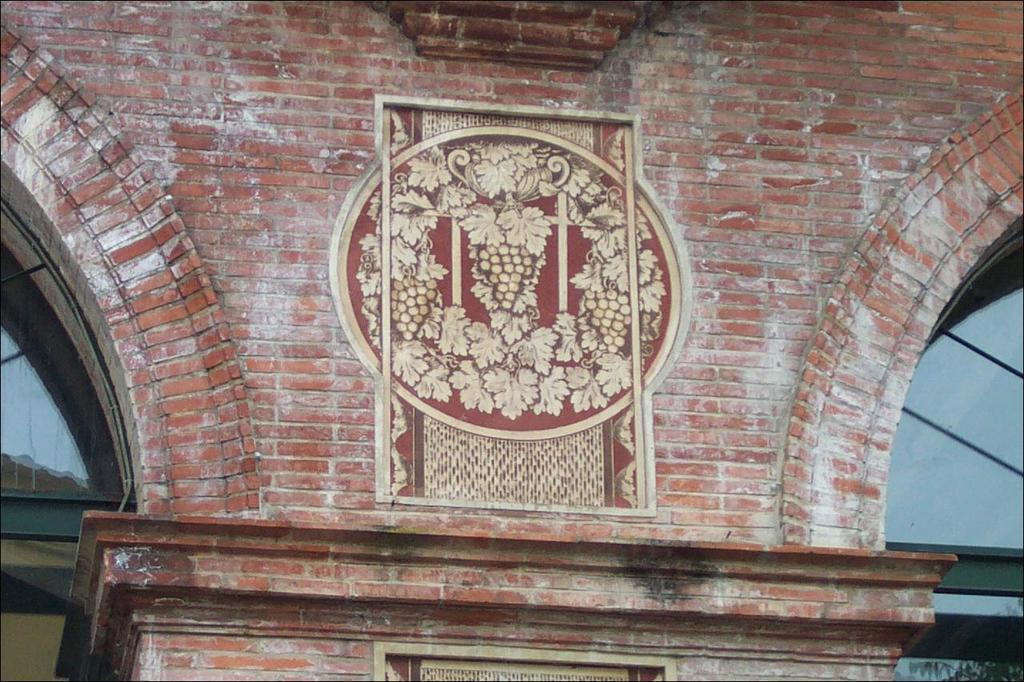What is the main subject in the foreground of the image? There is a wall of a building in the foreground of the image. Are there any architectural features present in the image? Yes, there are arches on either side of the image. What can be observed on the wall of the building? There is a design on the wall. How many cows can be seen grazing in the image? There are no cows present in the image; it features a wall of a building with arches and a design. 